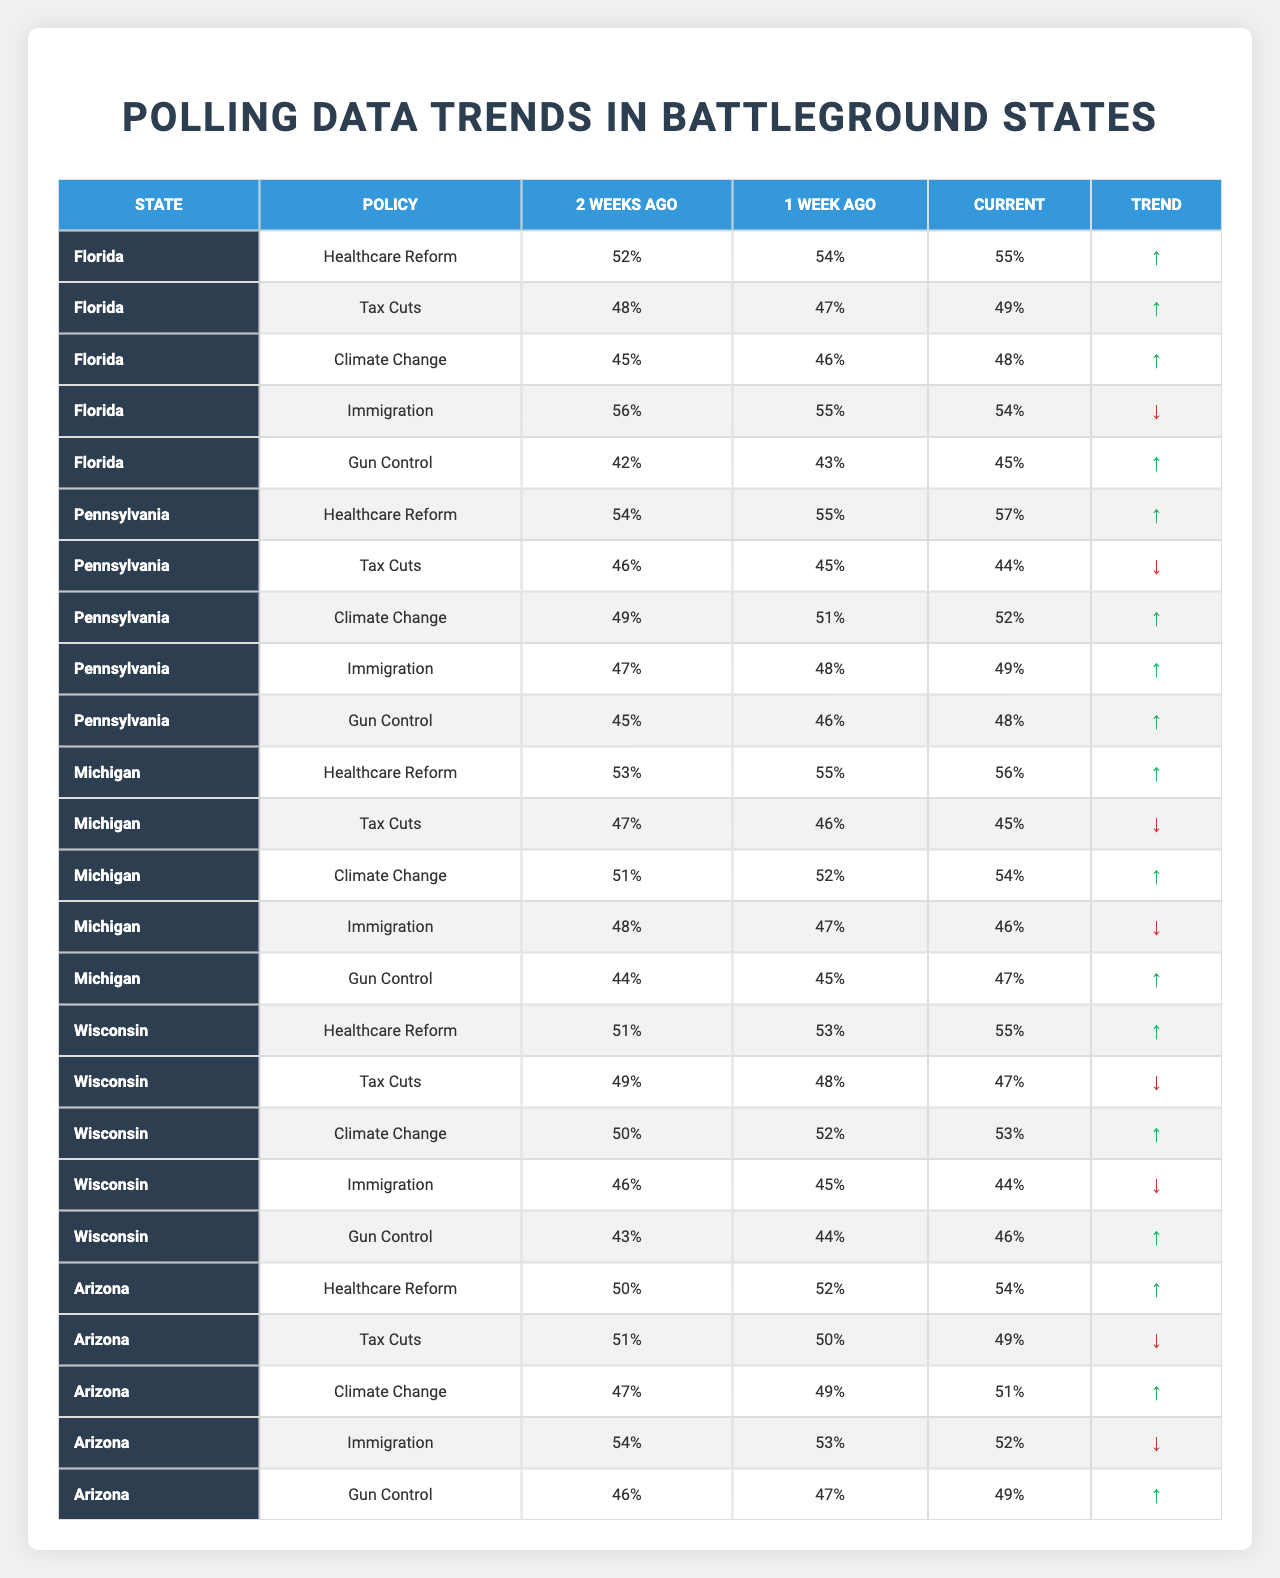What is the highest percentage support for Immigration reform among the states? Looking at the table, Florida has a current support percentage of 54% for Immigration reform, Arizona has 52%, Pennsylvania has 49%, Michigan has 46%, and Wisconsin has 44%. So, the highest support is 54% in Florida.
Answer: 54% Which state showed the most improvement in support for Healthcare Reform from two weeks ago to current? By comparing the Healthcare Reform percentages, Florida went from 52% to 55%, Pennsylvania from 54% to 57%, Michigan from 53% to 56%, Wisconsin from 51% to 55%, and Arizona from 50% to 54%. The largest improvement is 3% in Pennsylvania.
Answer: Pennsylvania Is there any state where support for Tax Cuts decreased over the last two weeks? By examining the Tax Cuts row, Florida showed a slight decrease from 48% two weeks ago to 49% currently. However, Pennsylvania's support decreased from 46% two weeks ago to 44% current, which confirms that there is a state with decreasing support for Tax Cuts.
Answer: Yes What is the average support for Gun Control in all states currently? The current support percentages for Gun Control are: Florida 45%, Pennsylvania 48%, Michigan 47%, Wisconsin 46%, and Arizona 49%. Adding these percentages gives 45 + 48 + 47 + 46 + 49 = 235. Dividing by the number of states (5) results in 235 / 5 = 47.
Answer: 47% Which state has the highest current percentage for Climate Change and how much is it? Looking at the Climate Change support levels, Michigan has 54%, Florida has 48%, Pennsylvania has 52%, Wisconsin has 53%, and Arizona has 51%. The highest percentage is thus 54% in Michigan.
Answer: 54% Did any state maintain the same support percentage for Gun Control over the last two weeks? Reviewing the Gun Control percentages, Florida went from 42% to 43% and then to 45%. Pennsylvania went from 45% to 46% and then to 48%. Michigan went from 44% to 45% and then to 47%. Wisconsin increased from 43% to 44%, then to 46%. Arizona went from 46% to 47%, then 49%. There was no state that maintained a consistent percentage in this timeframe.
Answer: No Which state had the most significant decrease in support for Tax Cuts from two weeks ago to the current percentage? Analyzing the Tax Cuts data: Florida decreased from 48% to 49% (+1), Pennsylvania decreased from 46% to 44% (-2), Michigan decreased from 47% to 45% (-2), Wisconsin decreased from 49% to 47% (-2), and Arizona decreased from 51% to 49% (-2). The most significant decrease is a 2% drop in multiple states, but the highest specific decrease is by Pennsylvania.
Answer: Pennsylvania What can you infer about the trend for Climate Change support in Wisconsin? Wisconsin's support for Climate Change went from 50% two weeks ago to 52% last week and then to 53% currently. This pattern indicates a consistent upward trend in support for Climate Change in Wisconsin over the measured time frame.
Answer: Upward trend Are there any states that have higher percentages in Gun Control than their percentages in Immigration currently? Reviewing the current support for Gun Control and Immigration: Florida has 45% (Gun Control) and 54% (Immigration), Pennsylvania has 48% (Gun Control) and 49% (Immigration), Michigan has 47% (Gun Control) and 46% (Immigration), Wisconsin has 46% (Gun Control) and 44% (Immigration), and Arizona has 49% (Gun Control) and 52% (Immigration). Thus, Michigan and Wisconsin show higher percentages in Gun Control compared to Immigration.
Answer: Yes Which policy saw a consistent increase across all states in the last week? Looking at the available data, Healthcare Reform increased in all states, from Florida (54% to 55%), Pennsylvania (55% to 57%), Michigan (55% to 56%), Wisconsin (53% to 55%), and Arizona (52% to 54%). This indicates that Healthcare Reform saw a consistent increase in support.
Answer: Yes 